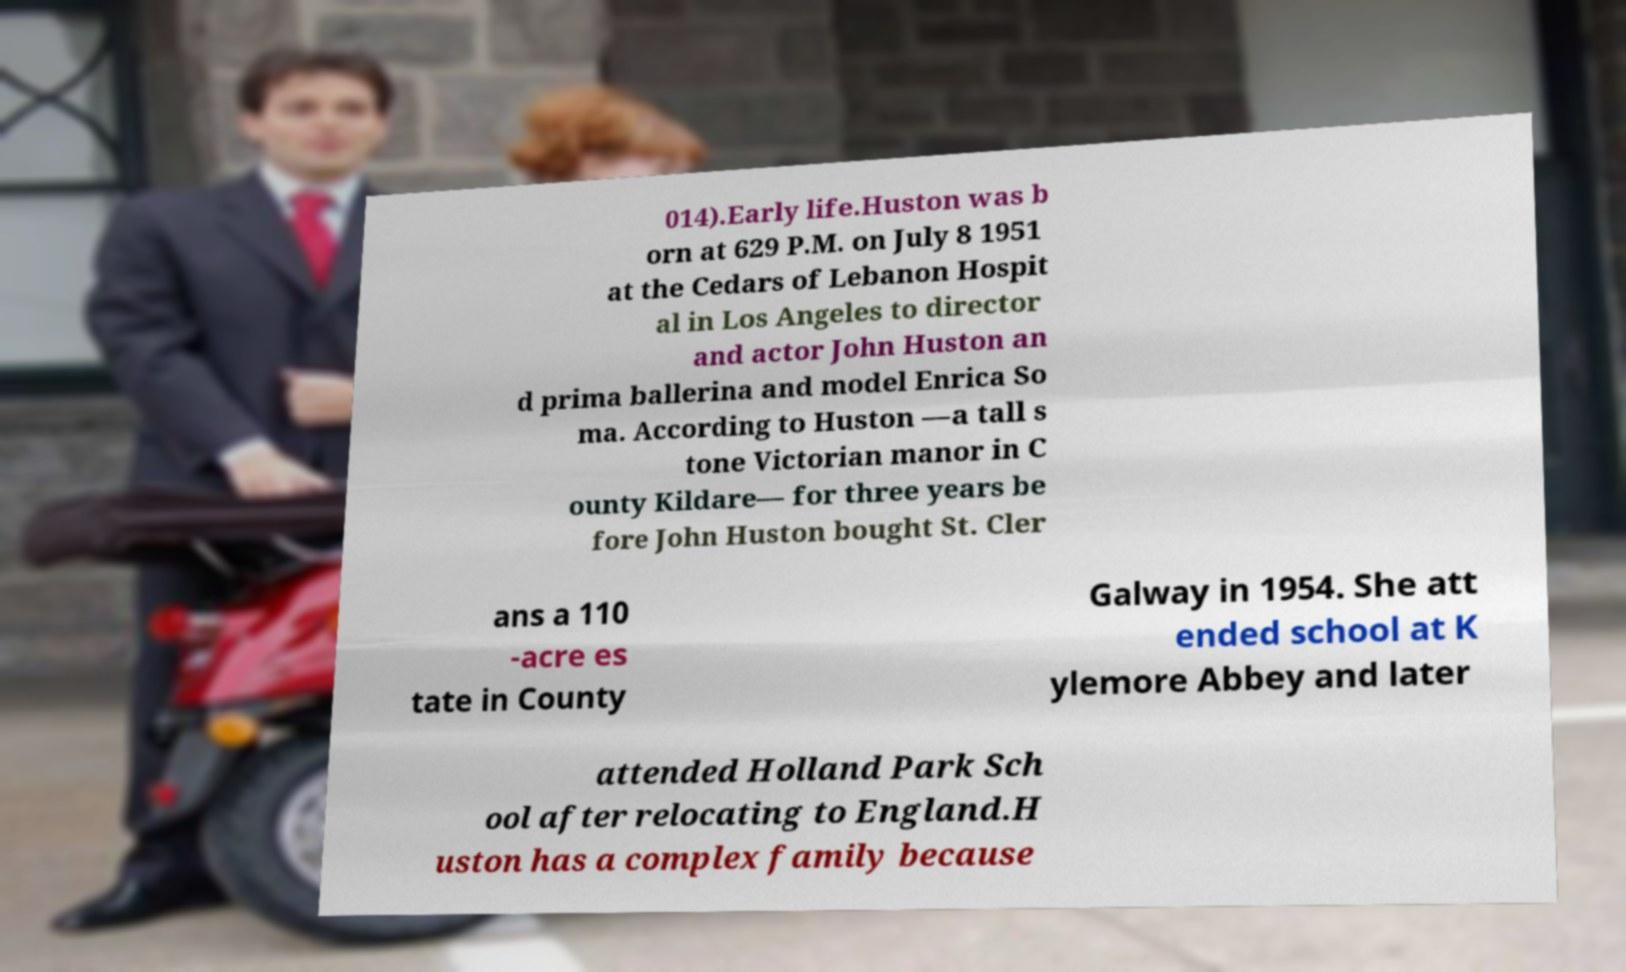Could you assist in decoding the text presented in this image and type it out clearly? 014).Early life.Huston was b orn at 629 P.M. on July 8 1951 at the Cedars of Lebanon Hospit al in Los Angeles to director and actor John Huston an d prima ballerina and model Enrica So ma. According to Huston —a tall s tone Victorian manor in C ounty Kildare— for three years be fore John Huston bought St. Cler ans a 110 -acre es tate in County Galway in 1954. She att ended school at K ylemore Abbey and later attended Holland Park Sch ool after relocating to England.H uston has a complex family because 